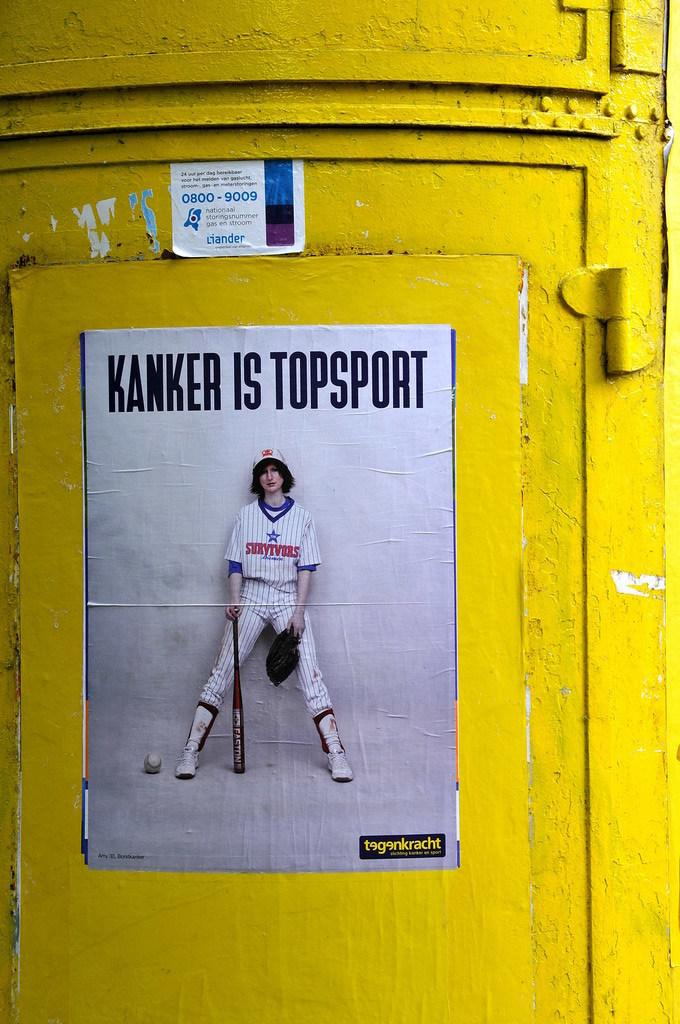<image>
Relay a brief, clear account of the picture shown. An ad on a wall says Kanker is topsport. 